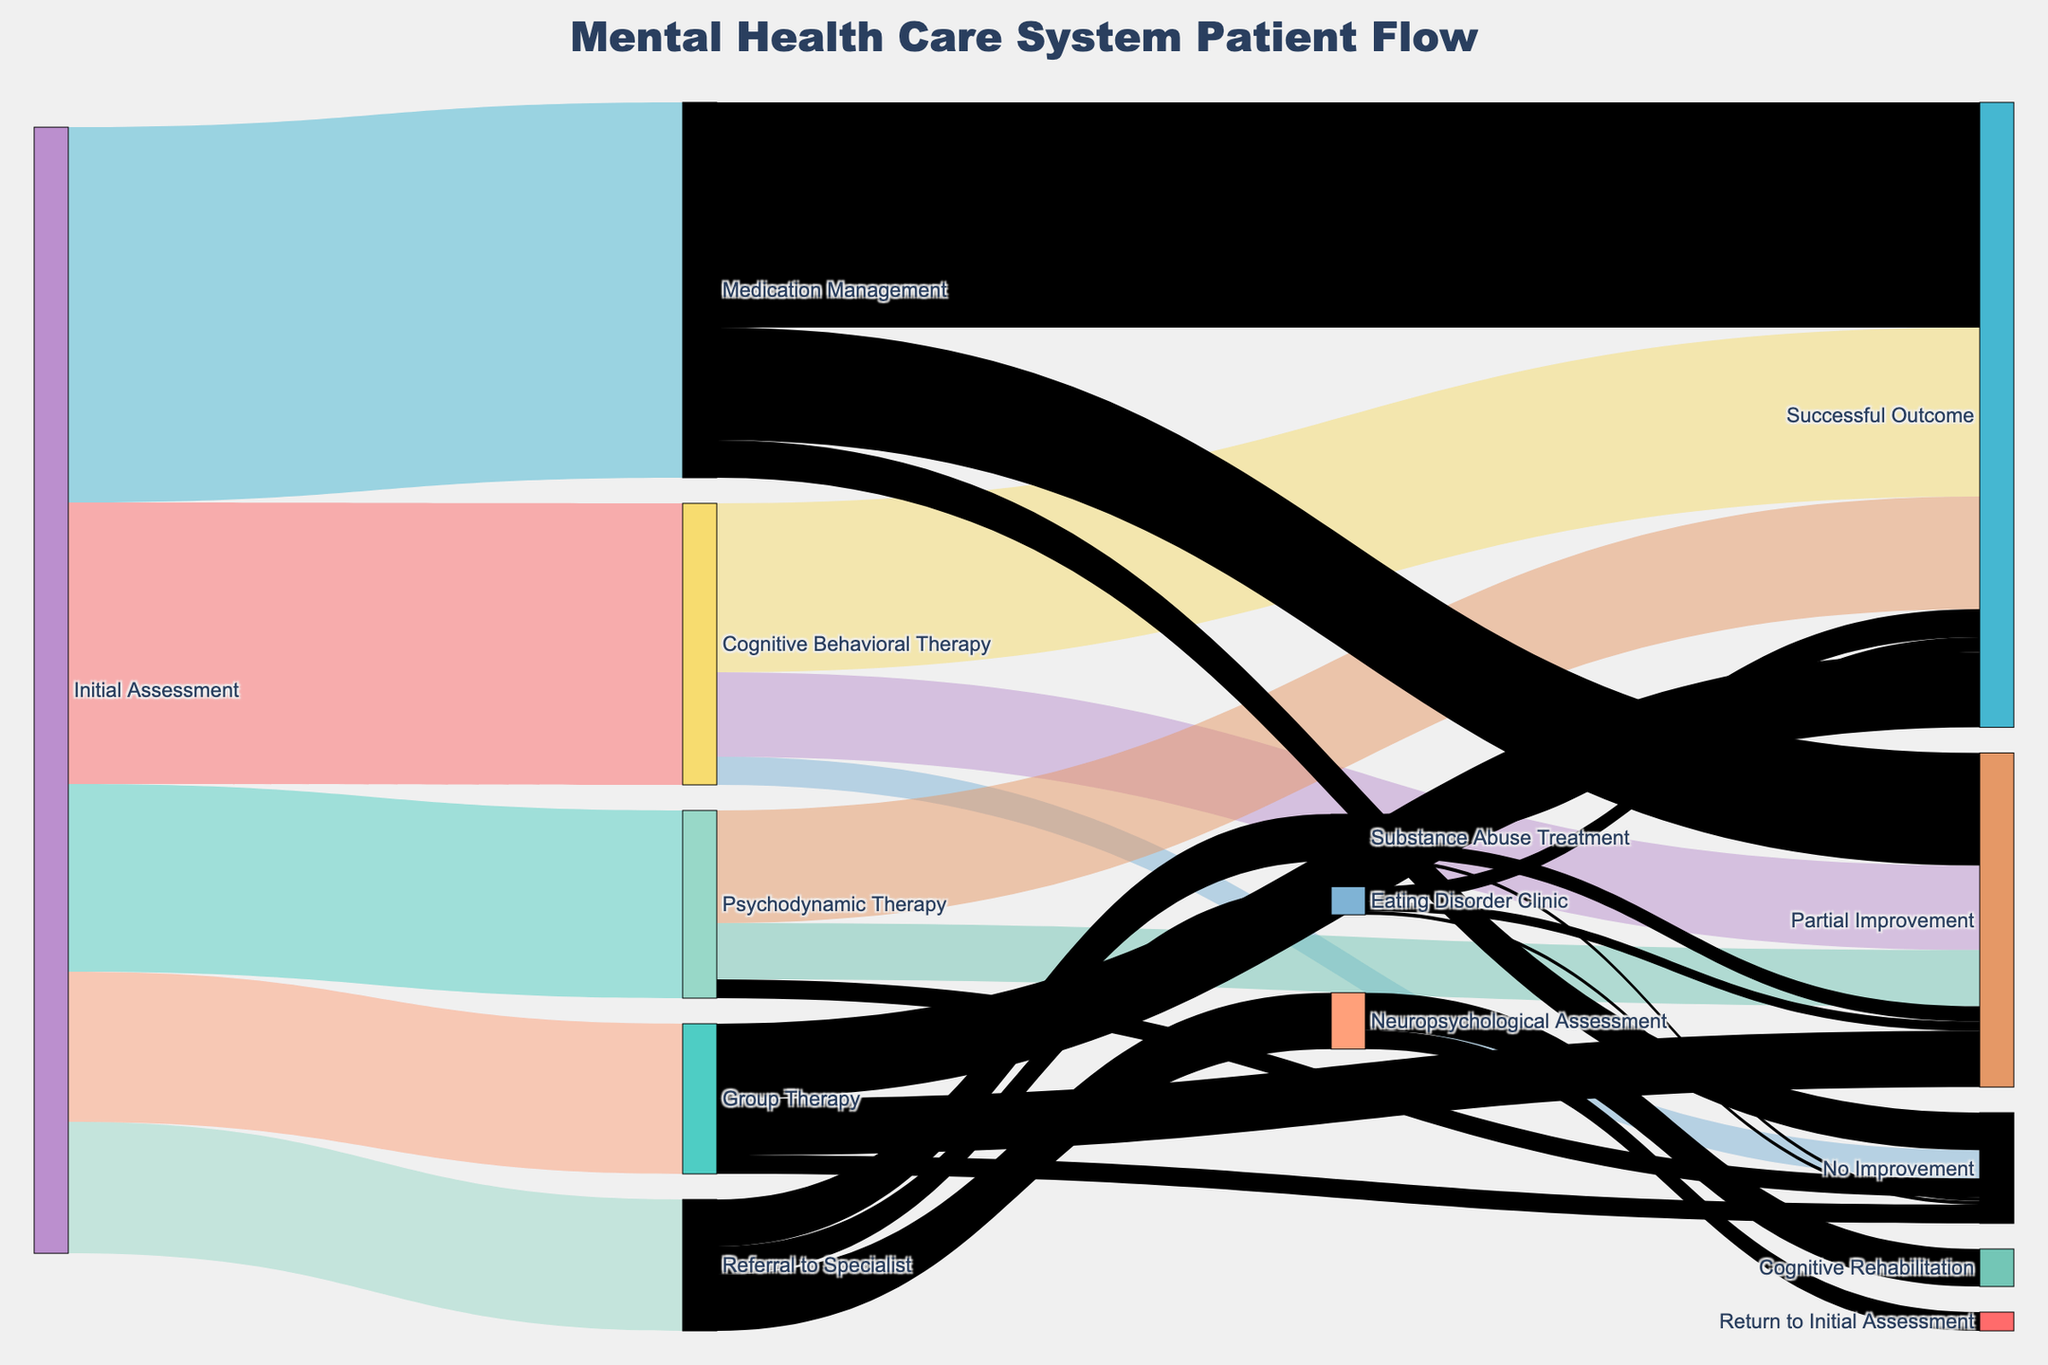Basic questions explanation
Answer: concise answer What is the title of the figure? The title is usually found at the top of the figure. In this case, it is clearly stated in the generated plot by the provided code.
Answer: Mental Health Care System Patient Flow How many patients were initially referred to a specialist? Look for the flow from "Initial Assessment" to "Referral to Specialist" and observe its corresponding value.
Answer: 70 What are the treatment paths after the initial assessment? Look for all the flows stemming from "Initial Assessment" to different treatment paths in the figure.
Answer: Cognitive Behavioral Therapy, Psychodynamic Therapy, Medication Management, Group Therapy, Referral to Specialist Compositional questions explanation
Answer: concise answer What is the total number of patients who experienced a successful outcome across all treatments? Add the values of flows that lead to "Successful Outcome" from all possible treatment paths. This includes successful outcomes from Cognitive Behavioral Therapy, Psychodynamic Therapy, Medication Management, Group Therapy, Substance Abuse Treatment, and Eating Disorder Clinic.
Answer: 90 + 60 + 120 + 40 + 15 + 8 = 333 How many patients were partially or not improved after attending Group Therapy? Sum the values of flows leading to "Partial Improvement" and "No Improvement" after "Group Therapy".
Answer: 30 + 10 = 40 Comparison questions explanation
Answer: concise answer Which treatment had the highest number of patients after the initial assessment? Compare the values of all flows stemming from "Initial Assessment" to different treatments and identify the highest one.
Answer: Medication Management Which specialized referral category had the least number of patients and how many? Compare the values of flows from "Referral to Specialist" to different specialized treatments and identify the smallest one.
Answer: Eating Disorder Clinic, 15 Chart-Type Specific questions explanation
Answer: concise answer How many different therapies are depicted in the figure after the initial assessment? Count the distinct therapies listed as flows from "Initial Assessment".
Answer: 5 (Cognitive Behavioral Therapy, Psychodynamic Therapy, Medication Management, Group Therapy, Referral to Specialist) Which therapy showed the highest success rate and what was the value? To determine the highest success rate, divide the number of successful outcomes by the initial number of patients for each therapy and compare them. For example, Cognitive Behavioral Therapy has a success rate of 90/150 = 60%. Perform this calculation for all therapies.
Answer: Medication Management, 60% What is the relationship between "Neuropsychological Assessment" and "Cognitive Rehabilitation"? Trace the flow connections from "Referral to Specialist" to "Neuropsychological Assessment" and then to "Cognitive Rehabilitation" to understand their linkage.
Answer: Patients from Neuropsychological Assessment are referred to Cognitive Rehabilitation 